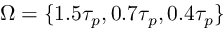Convert formula to latex. <formula><loc_0><loc_0><loc_500><loc_500>\Omega = \{ 1 . 5 \tau _ { p } , 0 . 7 \tau _ { p } , 0 . 4 \tau _ { p } \}</formula> 